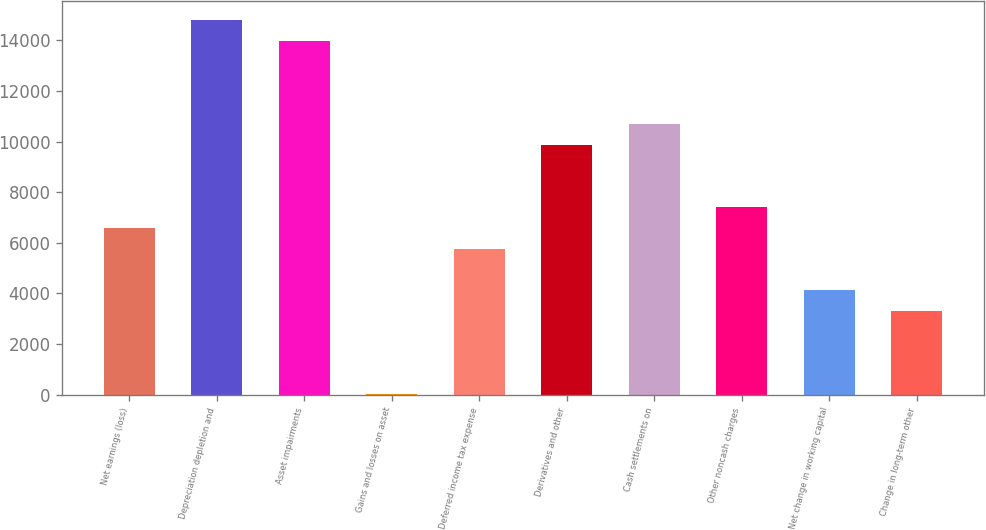Convert chart. <chart><loc_0><loc_0><loc_500><loc_500><bar_chart><fcel>Net earnings (loss)<fcel>Depreciation depletion and<fcel>Asset impairments<fcel>Gains and losses on asset<fcel>Deferred income tax expense<fcel>Derivatives and other<fcel>Cash settlements on<fcel>Other noncash charges<fcel>Net change in working capital<fcel>Change in long-term other<nl><fcel>6582.6<fcel>14794.6<fcel>13973.4<fcel>13<fcel>5761.4<fcel>9867.4<fcel>10688.6<fcel>7403.8<fcel>4119<fcel>3297.8<nl></chart> 